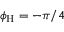Convert formula to latex. <formula><loc_0><loc_0><loc_500><loc_500>\phi _ { H } = - \pi / 4</formula> 